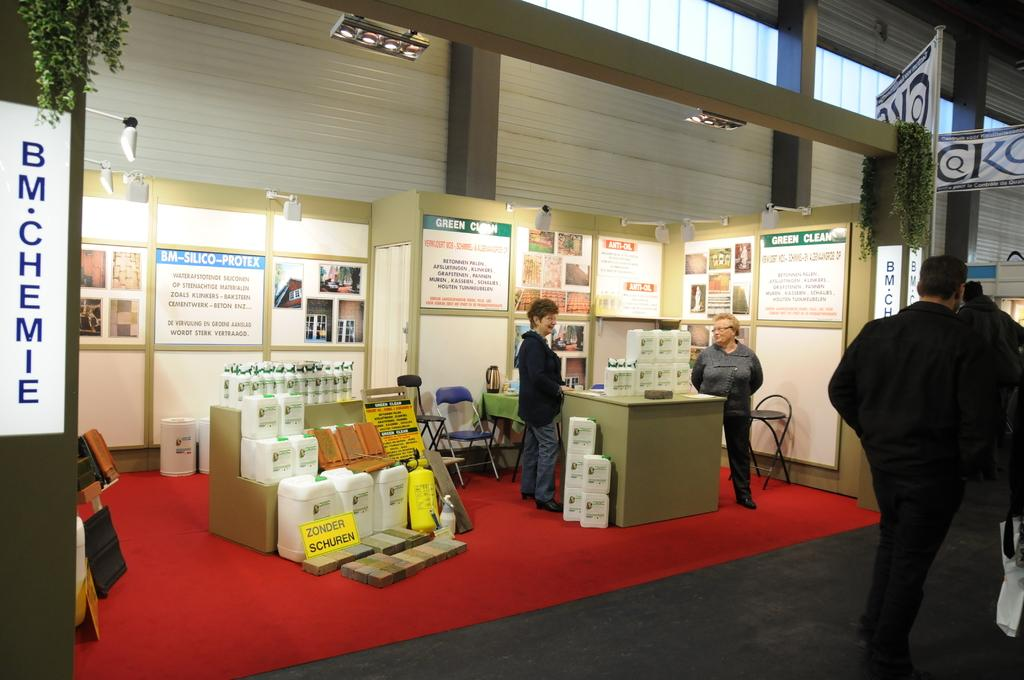Who or what is present in the image? There are people in the image. What can be found on the floor in the image? There are objects on the floor in the image. What is visible at the top of the image? There are lights visible at the top of the image. Can you see any chickens in the image? There are no chickens present in the image. Is there a trampoline visible in the image? There is no trampoline present in the image. 